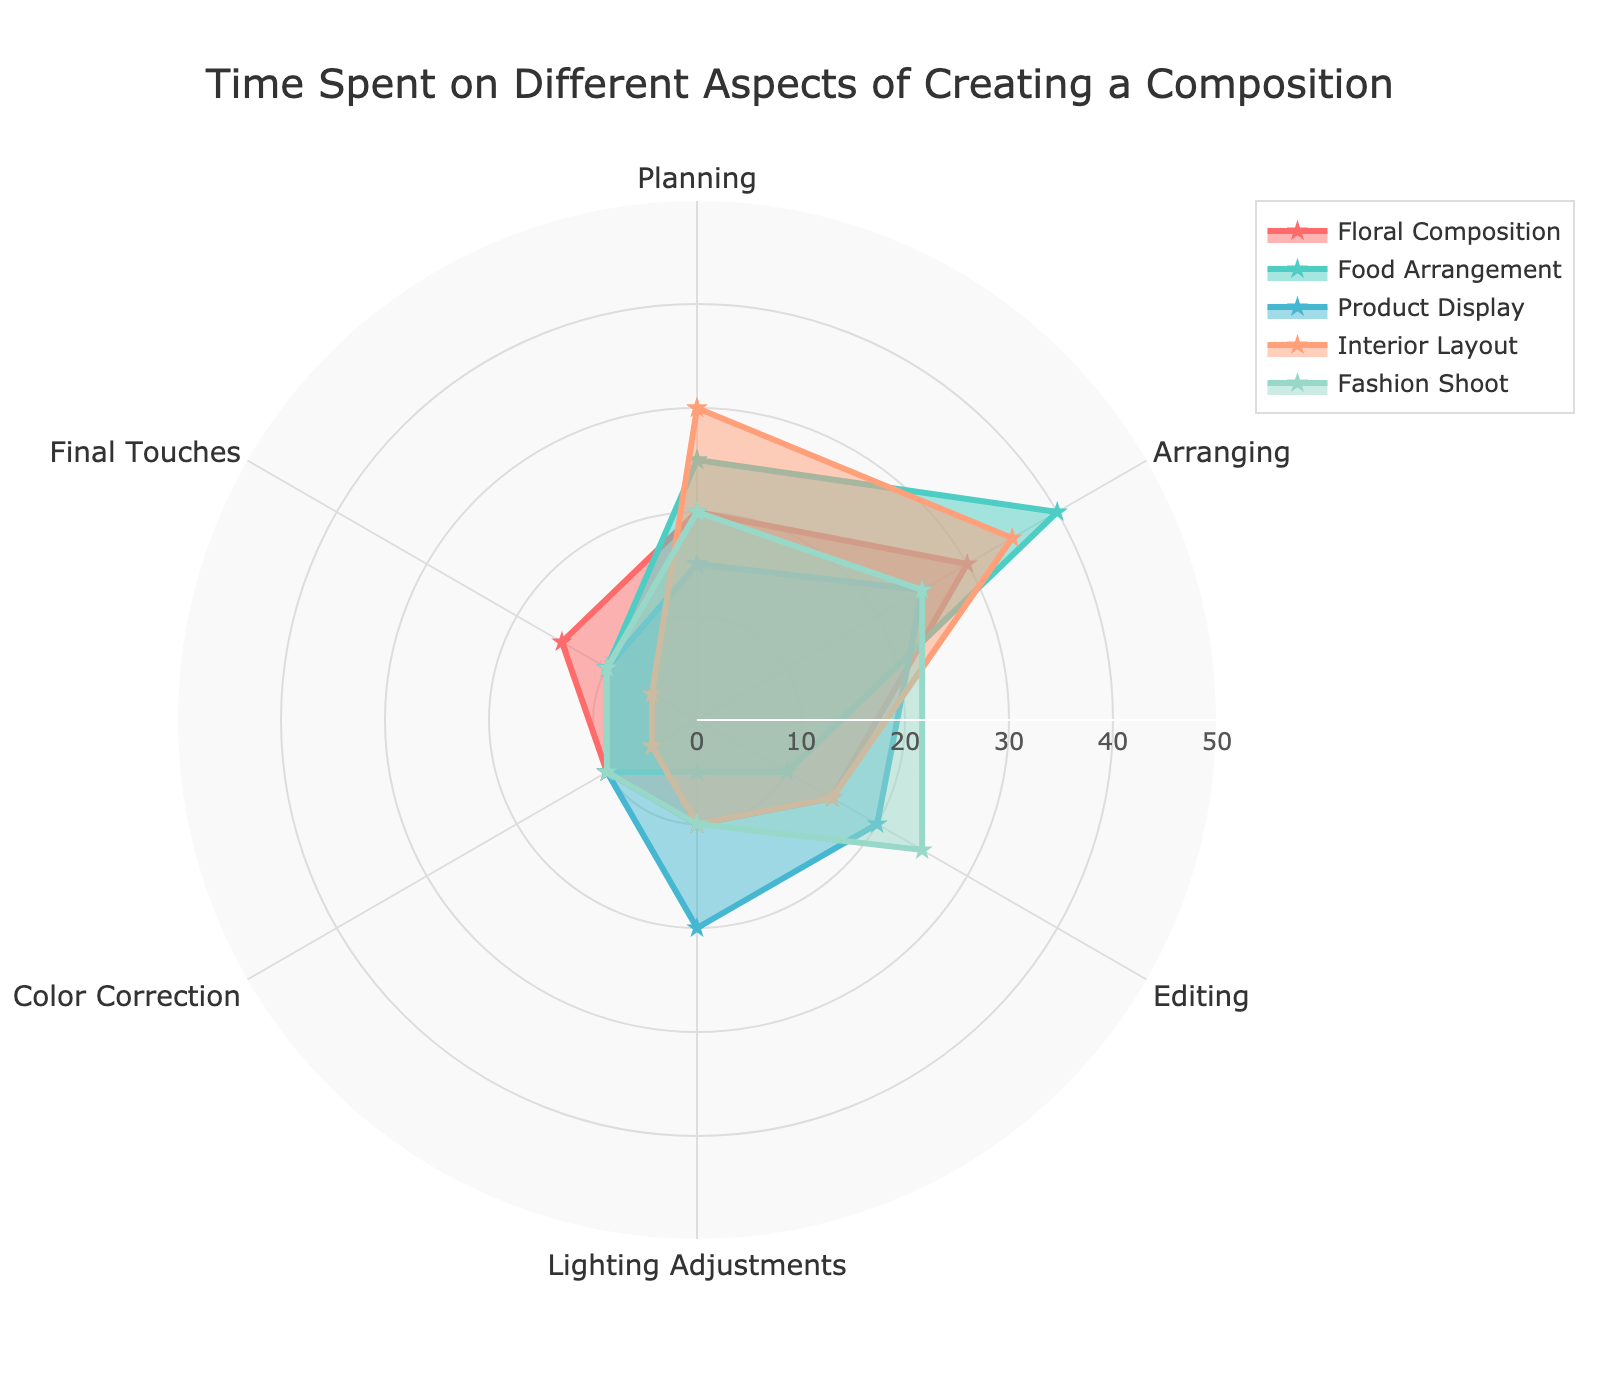What is the title of the radar chart? The title is located at the top of the chart.
Answer: Time Spent on Different Aspects of Creating a Composition Which category spends the most time on arranging? Compare the value for arranging across all categories.
Answer: Food Arrangement What is the overall range of the radial axis? The range is indicated by the labels on the radial axis.
Answer: 0 to 50 What's the combined time spent on planning and arranging for Interior Layout? Add the values for planning (30) and arranging (35).
Answer: 65 Which category has the highest time spent on lighting adjustments? Compare the values for lighting adjustments across all categories.
Answer: Product Display How many categories are presented in the chart? Count the number of categories listed in the chart's legend.
Answer: 5 What is the time spent on final touches for Food Arrangement compared to Floral Composition? Compare the values for final touches in both categories (10 and 15).
Answer: Floral Composition spends more time Which aspect has the lowest value in all categories combined? Identify the aspect with the lowest sum across all categories.
Answer: Color Correction If you average the time spent on editing across all categories, what is the value? Add the values for editing (15, 10, 20, 15, 25) and divide by the number of categories (5). Detailed: (15 + 10 + 20 + 15 + 25) / 5 = 85 / 5.
Answer: 17 Which category shows an almost equal distribution of time across all aspects? Identify the category where the values are most similar (Fashion Shoot: 20, 25, 25, 10, 10, 10).
Answer: Fashion Shoot 